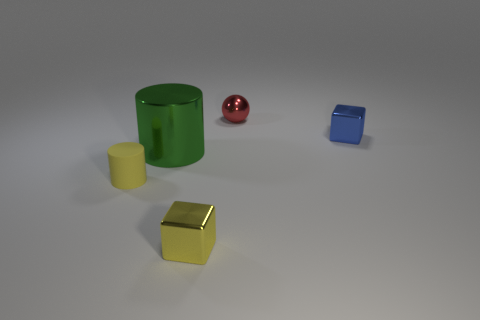Add 3 cyan cubes. How many objects exist? 8 Subtract all cylinders. How many objects are left? 3 Subtract 1 yellow cylinders. How many objects are left? 4 Subtract all large purple metal things. Subtract all yellow metallic blocks. How many objects are left? 4 Add 4 large green things. How many large green things are left? 5 Add 3 green objects. How many green objects exist? 4 